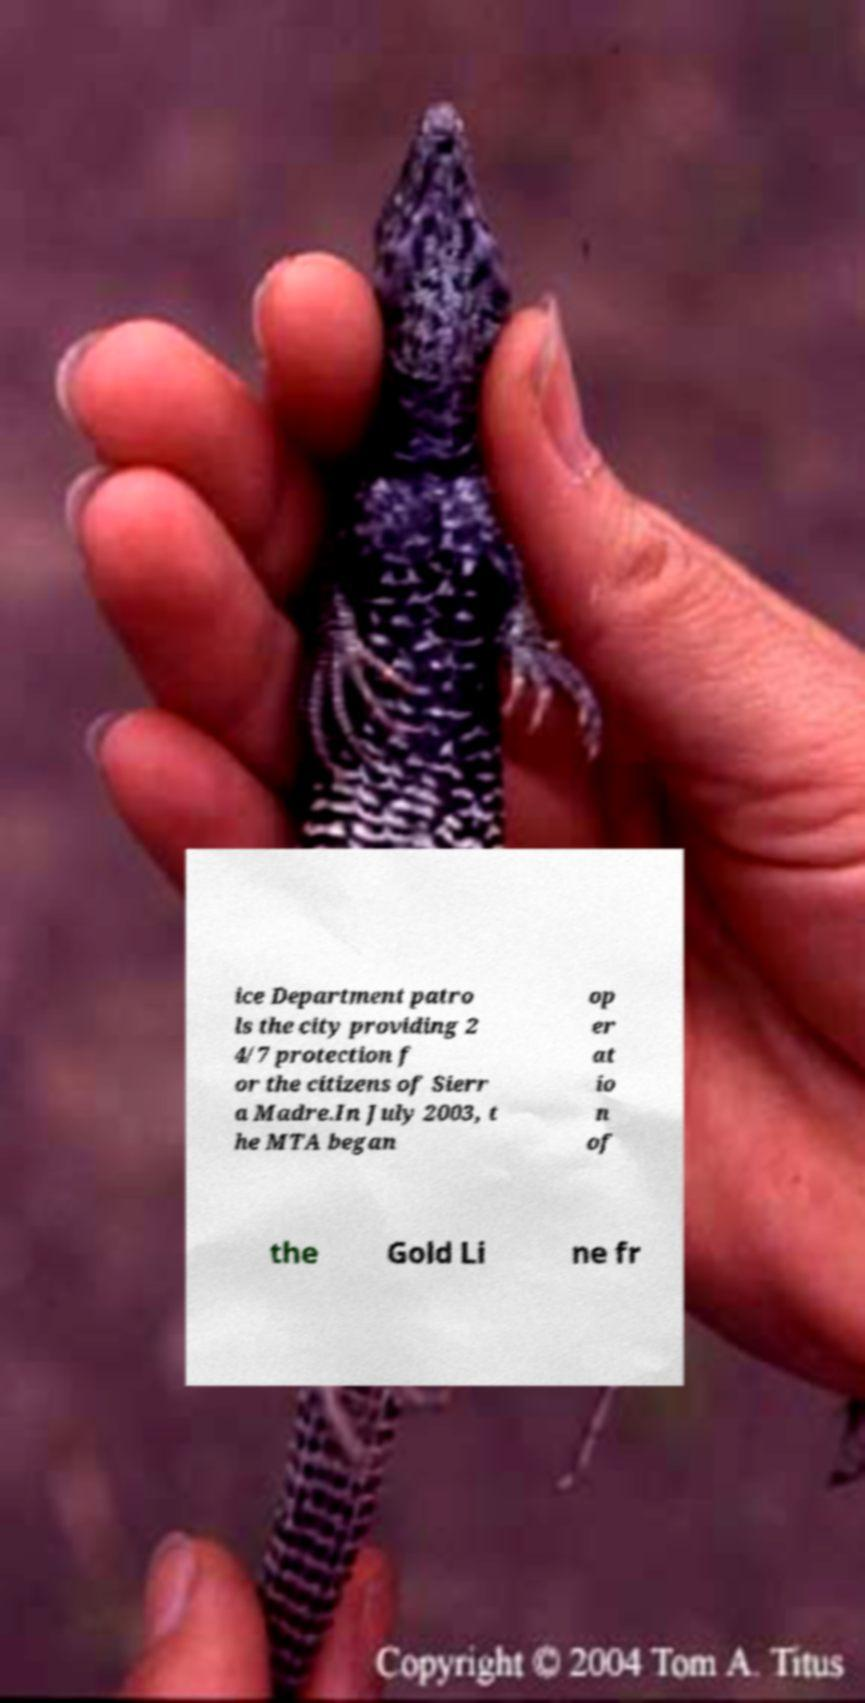Could you extract and type out the text from this image? ice Department patro ls the city providing 2 4/7 protection f or the citizens of Sierr a Madre.In July 2003, t he MTA began op er at io n of the Gold Li ne fr 